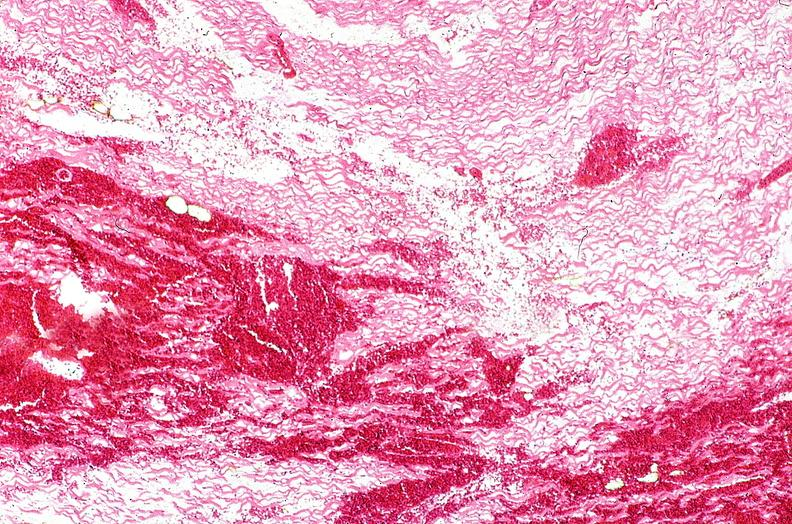does this image show heart, myocardial infarction, wavey fiber change, necrtosis, hemorrhage, and dissection?
Answer the question using a single word or phrase. Yes 